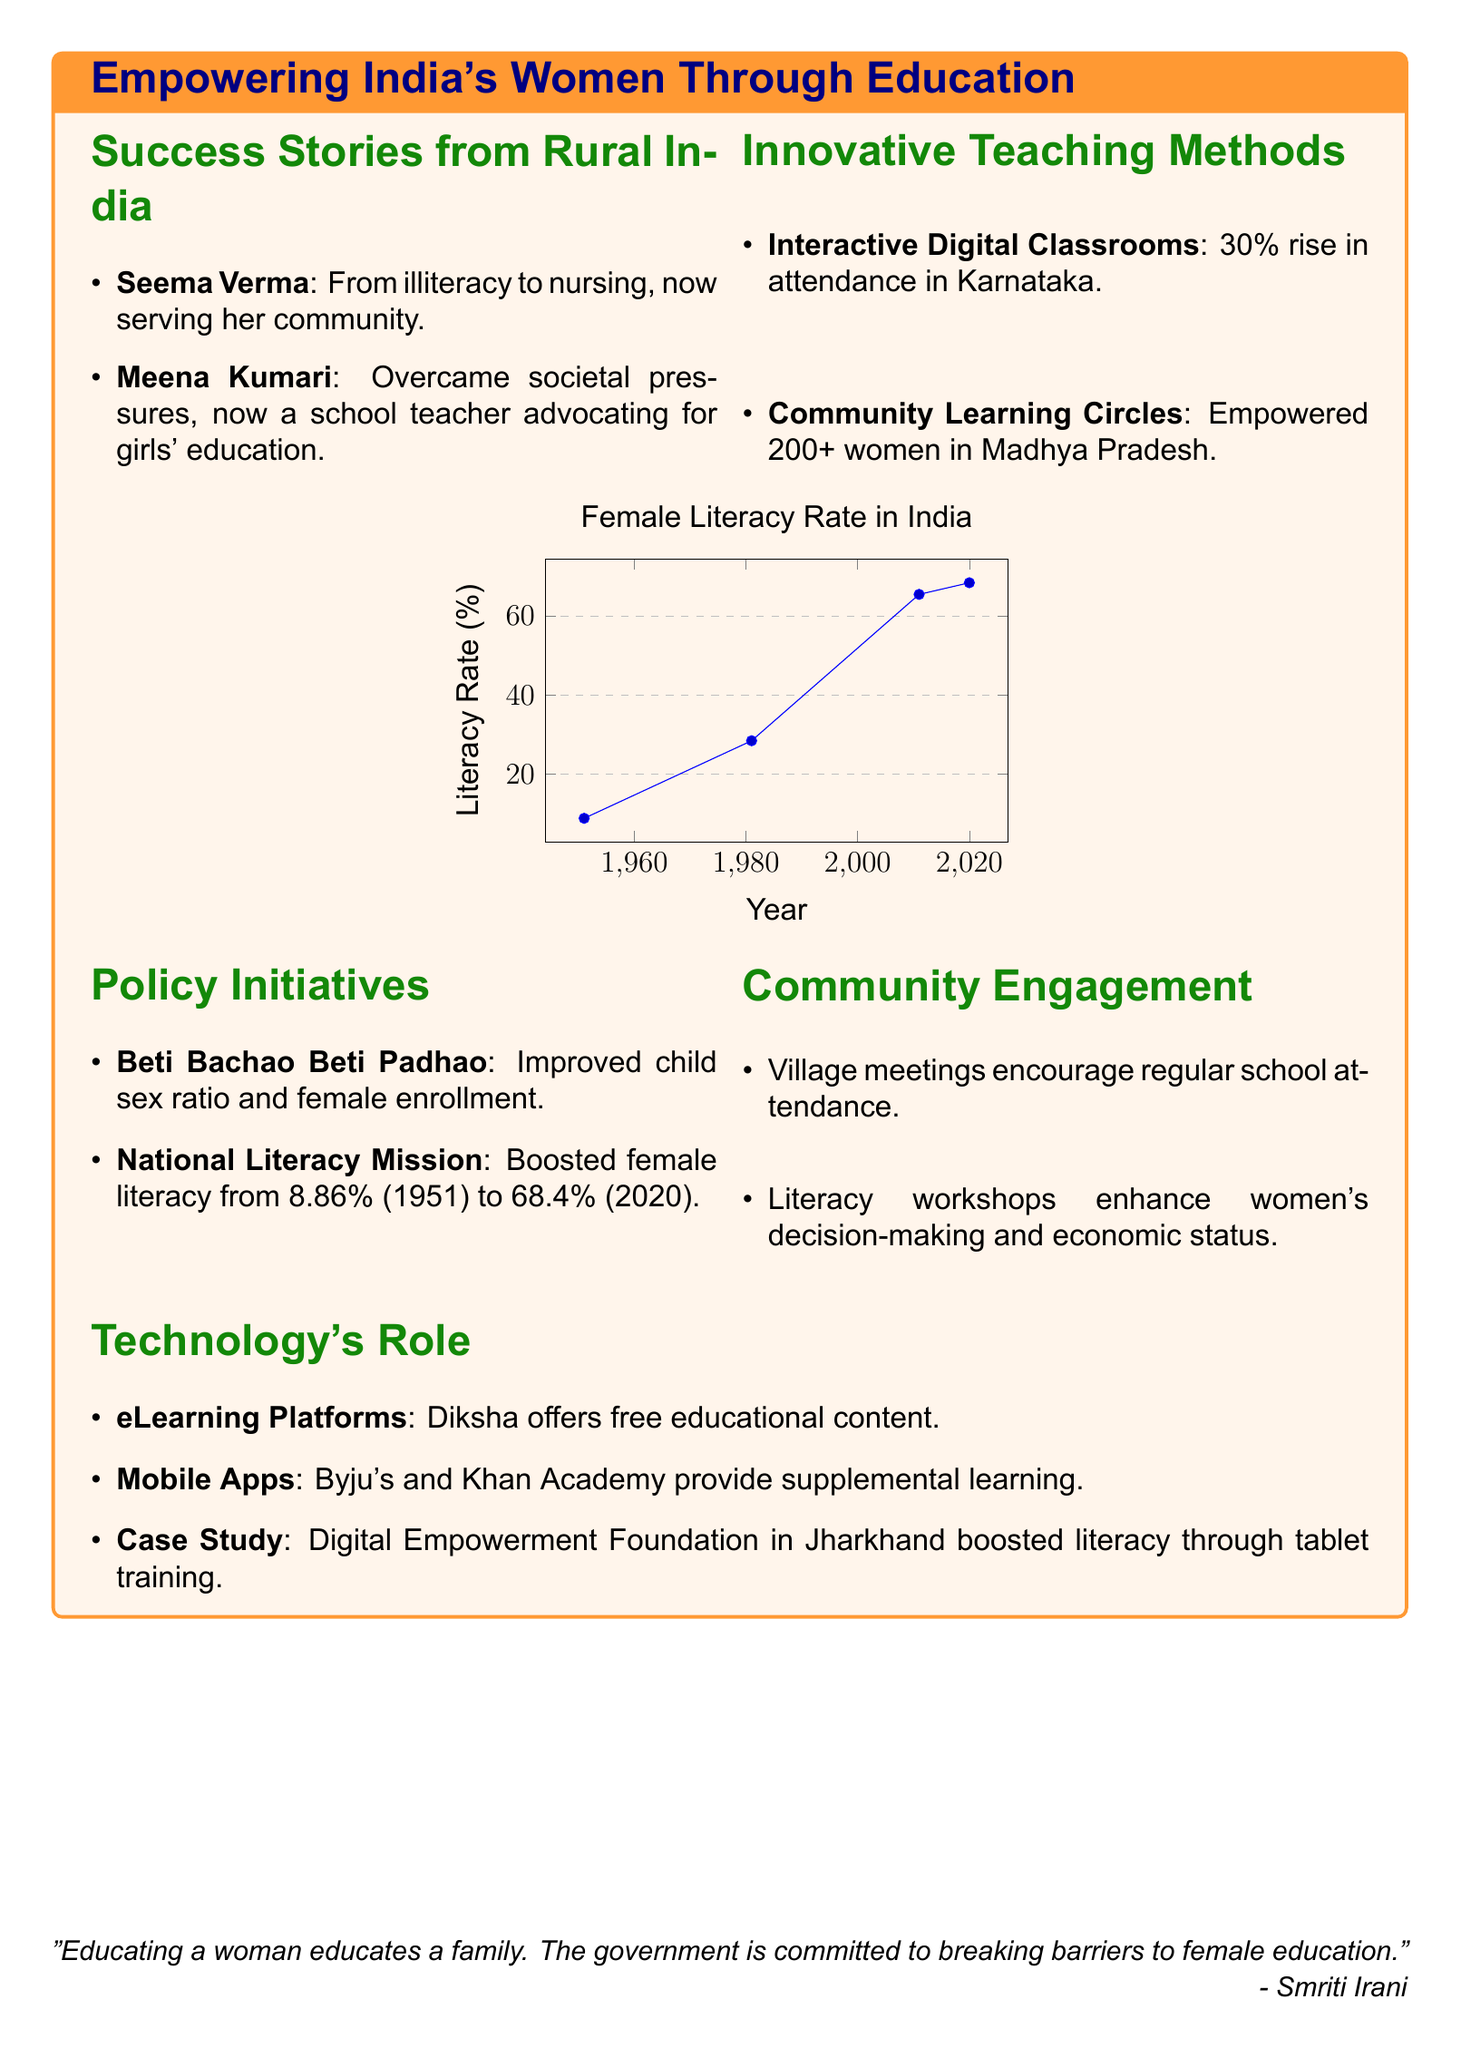What are the names of the two women featured in success stories? The document lists specific women who have achieved remarkable milestones through education, which are Seema Verma and Meena Kumari.
Answer: Seema Verma, Meena Kumari What teaching method had a 30% rise in attendance? The document mentions an innovative method that resulted in improved attendance rates, specifically in Karnataka.
Answer: Interactive Digital Classrooms What was the female literacy rate in India in 2011? The document provides historical female literacy rates, and the specific value for the year 2011 is stated.
Answer: 65.46% What is the name of the initiative aimed at improving the child sex ratio? The document includes policies that have been established, including a specific initiative mentioned for improving child sex ratio.
Answer: Beti Bachao Beti Padhao How many women were empowered through Community Learning Circles? The document states the number of women who benefited from this specific innovative teaching method.
Answer: 200+ What average literacy rate increase did the National Literacy Mission achieve from 1951 to 2020? The document highlights the impact of this mission, showing the difference between the literacy rates of these specific years.
Answer: 59.54% What role does Diksha play in female literacy? The document identifies the purpose of this technological resource, focusing on its contributions to education accessibility.
Answer: Offers free educational content Which technology significantly boosted literacy in Jharkhand? The document cites a specific case study related to a technological approach aimed at improving literacy rates in this region.
Answer: Digital Empowerment Foundation What is the significance of the quote from Smriti Irani? The document concludes with a quote emphasizing the government's commitment to female education, highlighting its impact on families.
Answer: "Educating a woman educates a family." 